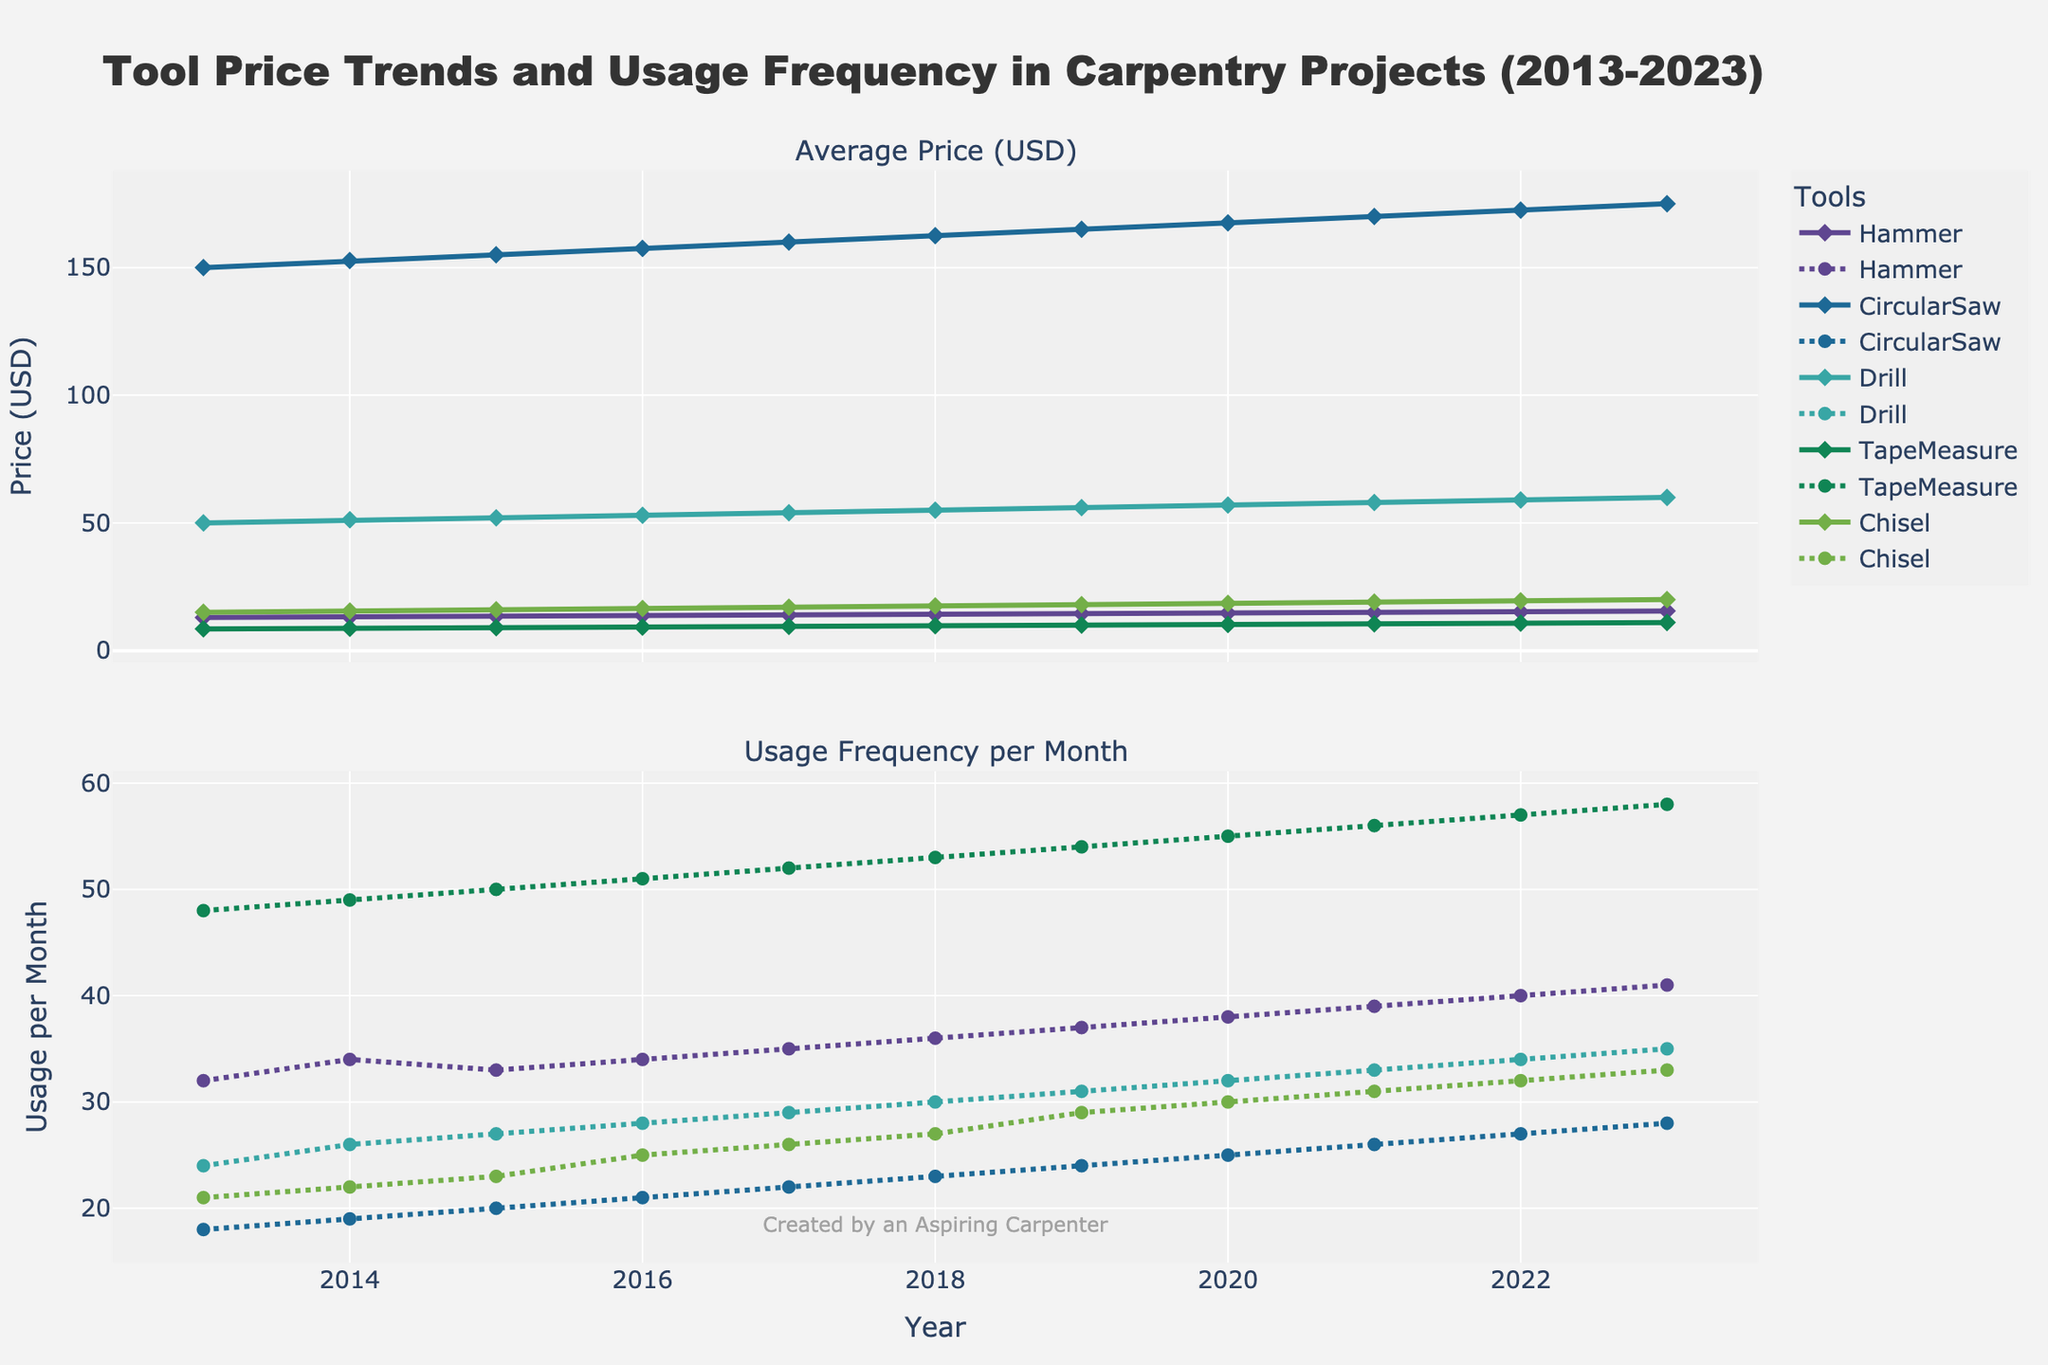What's the title of the figure? The title of the figure is displayed prominently at the top, providing context for the data presented.
Answer: Tool Price Trends and Usage Frequency in Carpentry Projects (2013-2023) What are the units used for the Y-axis on the top subplot? The Y-axis on the top subplot represents the average prices in USD, as indicated by the label "Price (USD)".
Answer: Price (USD) Which tool had the highest average price in 2023? By looking at the top subplot for the year 2023, we can see that the Circular Saw has the highest point on the price axis.
Answer: Circular Saw How has the usage frequency per month of the Tape Measure changed from 2013 to 2023? By observing the bottom subplot, we can trace the Tape Measure's line, noticing an overall increase in usage frequency from 48 times per month in 2013 to 58 times per month in 2023.
Answer: Increased In which year did the Drill’s price first exceed $50? By following the Drill's price line in the top subplot, the first year the price crosses the $50 mark is in 2014.
Answer: 2014 Which tool has shown a more consistent increase in usage frequency over the last decade: the Hammer or the Chisel? Tracking both lines in the bottom subplot, the Hammer shows a steadier increase in usage frequency, unlike the Chisel which has more variations.
Answer: Hammer What's the combined price of all tools in 2020? Summing up the prices of all tools for the year 2020: Hammer ($14.75) + Circular Saw ($167.50) + Drill ($57.00) + Tape Measure ($10.25) + Chisel ($18.50), we get $267.95.
Answer: $267.95 Between 2019 and 2020, which tool's usage frequency increased the most? Observing the bottom subplot for the years 2019 and 2020 reveals that the Drill's usage frequency increased the most, from 31 to 32 times per month.
Answer: Drill Has the price of the Circular Saw ever decreased in any year within the given period? Reviewing the top subplot for the Circular Saw's line, there is no year where its price decreases; it only increases or remains constant.
Answer: No 